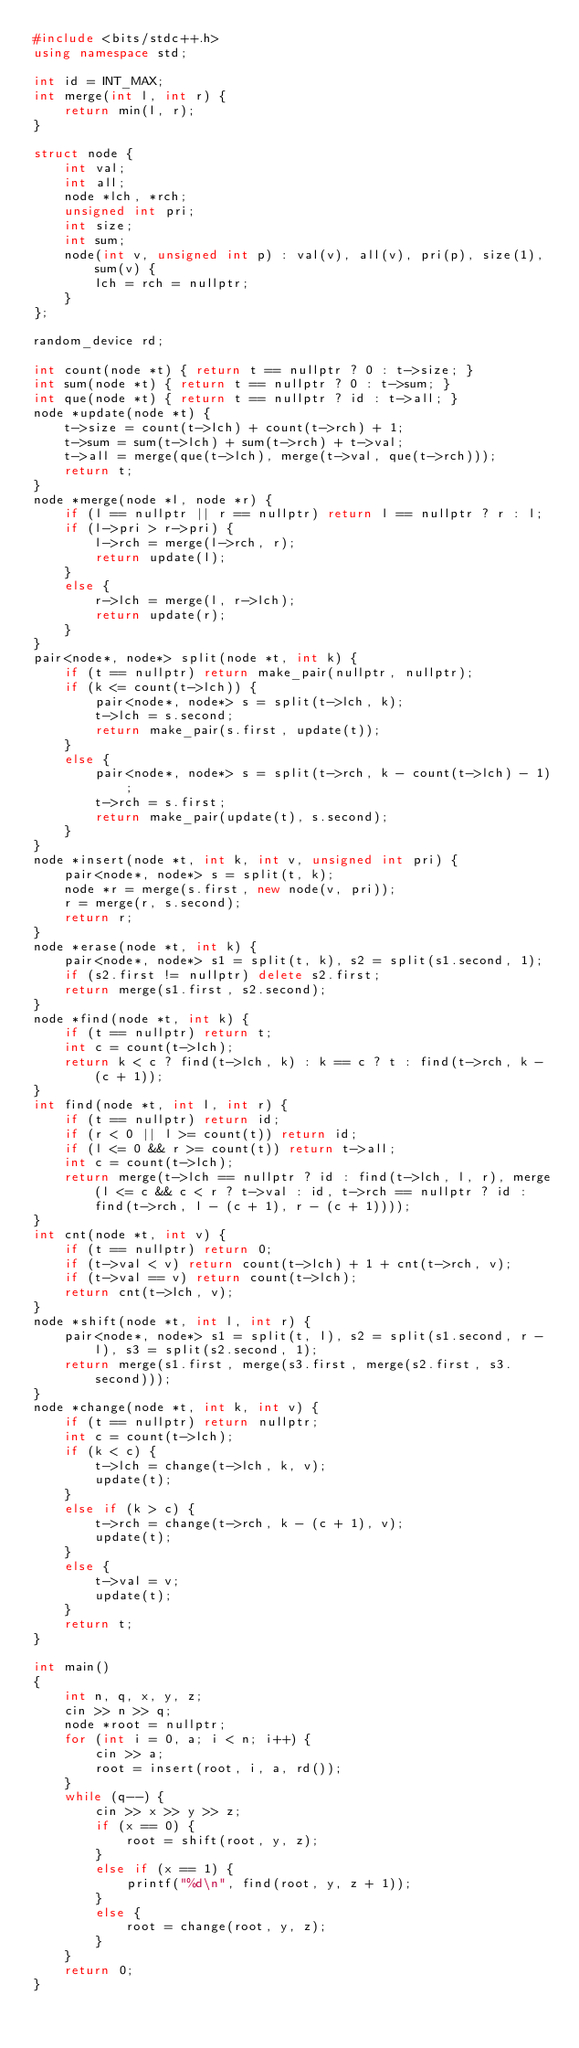<code> <loc_0><loc_0><loc_500><loc_500><_C++_>#include <bits/stdc++.h>
using namespace std;

int id = INT_MAX;
int merge(int l, int r) {
	return min(l, r);
}

struct node {
	int val;
	int all;
	node *lch, *rch;
	unsigned int pri;
	int size;
	int sum;
	node(int v, unsigned int p) : val(v), all(v), pri(p), size(1), sum(v) {
		lch = rch = nullptr;
	}
};

random_device rd;

int count(node *t) { return t == nullptr ? 0 : t->size; }
int sum(node *t) { return t == nullptr ? 0 : t->sum; }
int que(node *t) { return t == nullptr ? id : t->all; }
node *update(node *t) {
	t->size = count(t->lch) + count(t->rch) + 1;
	t->sum = sum(t->lch) + sum(t->rch) + t->val;
	t->all = merge(que(t->lch), merge(t->val, que(t->rch)));
	return t;
}
node *merge(node *l, node *r) {
	if (l == nullptr || r == nullptr) return l == nullptr ? r : l;
	if (l->pri > r->pri) {
		l->rch = merge(l->rch, r);
		return update(l);
	}
	else {
		r->lch = merge(l, r->lch);
		return update(r);
	}
}
pair<node*, node*> split(node *t, int k) {
	if (t == nullptr) return make_pair(nullptr, nullptr);
	if (k <= count(t->lch)) {
		pair<node*, node*> s = split(t->lch, k);
		t->lch = s.second;
		return make_pair(s.first, update(t));
	}
	else {
		pair<node*, node*> s = split(t->rch, k - count(t->lch) - 1);
		t->rch = s.first;
		return make_pair(update(t), s.second);
	}
}
node *insert(node *t, int k, int v, unsigned int pri) {
	pair<node*, node*> s = split(t, k);
	node *r = merge(s.first, new node(v, pri));
	r = merge(r, s.second);
	return r;
}
node *erase(node *t, int k) {
	pair<node*, node*> s1 = split(t, k), s2 = split(s1.second, 1);
	if (s2.first != nullptr) delete s2.first;
	return merge(s1.first, s2.second);
}
node *find(node *t, int k) {
	if (t == nullptr) return t;
	int c = count(t->lch);
	return k < c ? find(t->lch, k) : k == c ? t : find(t->rch, k - (c + 1));
}
int find(node *t, int l, int r) {
	if (t == nullptr) return id;
	if (r < 0 || l >= count(t)) return id;
	if (l <= 0 && r >= count(t)) return t->all;
	int c = count(t->lch);
	return merge(t->lch == nullptr ? id : find(t->lch, l, r), merge(l <= c && c < r ? t->val : id, t->rch == nullptr ? id : find(t->rch, l - (c + 1), r - (c + 1))));
}
int cnt(node *t, int v) {
	if (t == nullptr) return 0;
	if (t->val < v) return count(t->lch) + 1 + cnt(t->rch, v);
	if (t->val == v) return count(t->lch);
	return cnt(t->lch, v);
}
node *shift(node *t, int l, int r) {
	pair<node*, node*> s1 = split(t, l), s2 = split(s1.second, r - l), s3 = split(s2.second, 1);
	return merge(s1.first, merge(s3.first, merge(s2.first, s3.second)));
}
node *change(node *t, int k, int v) {
	if (t == nullptr) return nullptr;
	int c = count(t->lch);
	if (k < c) {
		t->lch = change(t->lch, k, v);
		update(t);
	}
	else if (k > c) {
		t->rch = change(t->rch, k - (c + 1), v);
		update(t);
	}
	else {
		t->val = v;
		update(t);
	}
	return t;
}

int main()
{
	int n, q, x, y, z;
	cin >> n >> q;
	node *root = nullptr;
	for (int i = 0, a; i < n; i++) {
		cin >> a;
		root = insert(root, i, a, rd());
	}
	while (q--) {
		cin >> x >> y >> z;
		if (x == 0) {
			root = shift(root, y, z);
		}
		else if (x == 1) {
			printf("%d\n", find(root, y, z + 1));
		}
		else {
			root = change(root, y, z);
		}
	}
	return 0;
}</code> 